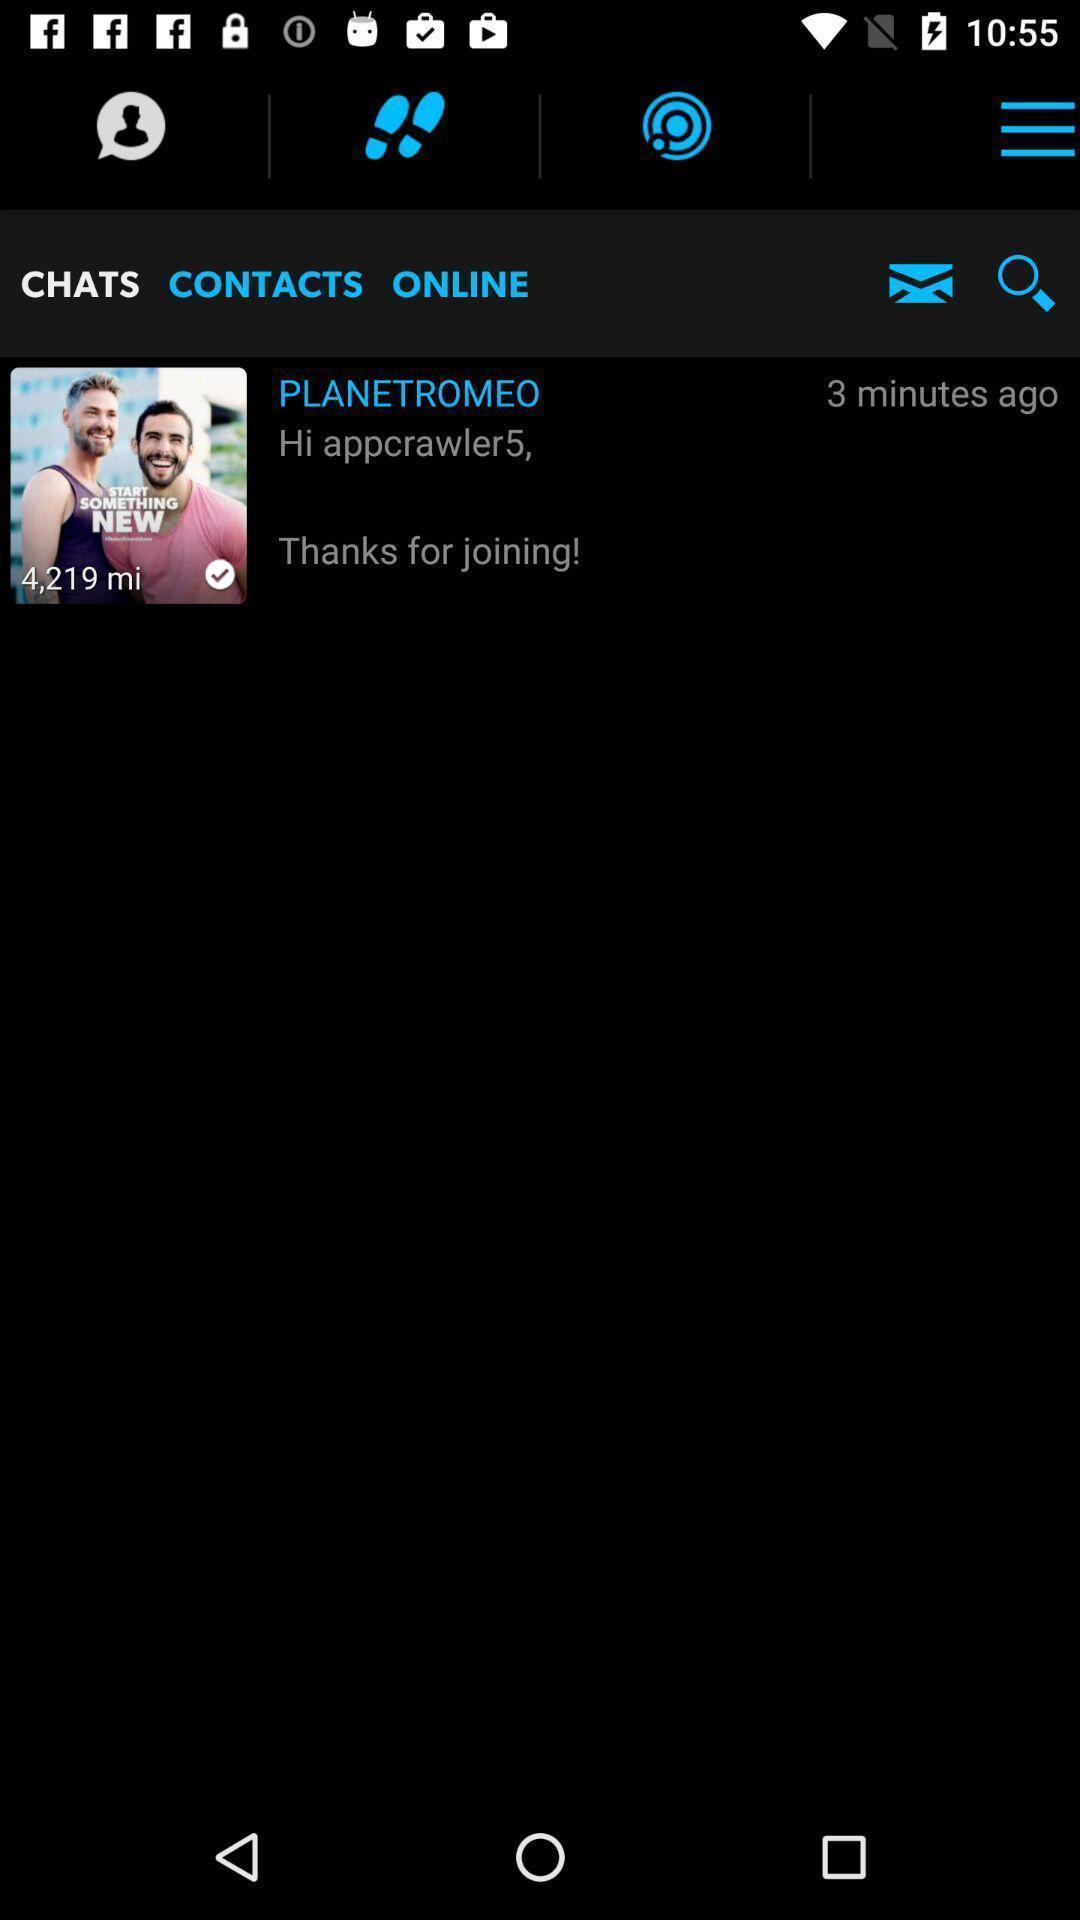Provide a description of this screenshot. Page showing a chatting profile. 